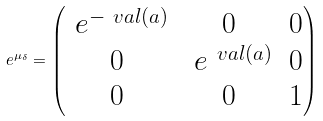<formula> <loc_0><loc_0><loc_500><loc_500>\ e ^ { \mu _ { \delta } } = \begin{pmatrix} \ e ^ { - \ v a l ( a ) } & 0 & 0 \\ 0 & \ e ^ { \ v a l ( a ) } & 0 \\ 0 & 0 & 1 \end{pmatrix}</formula> 